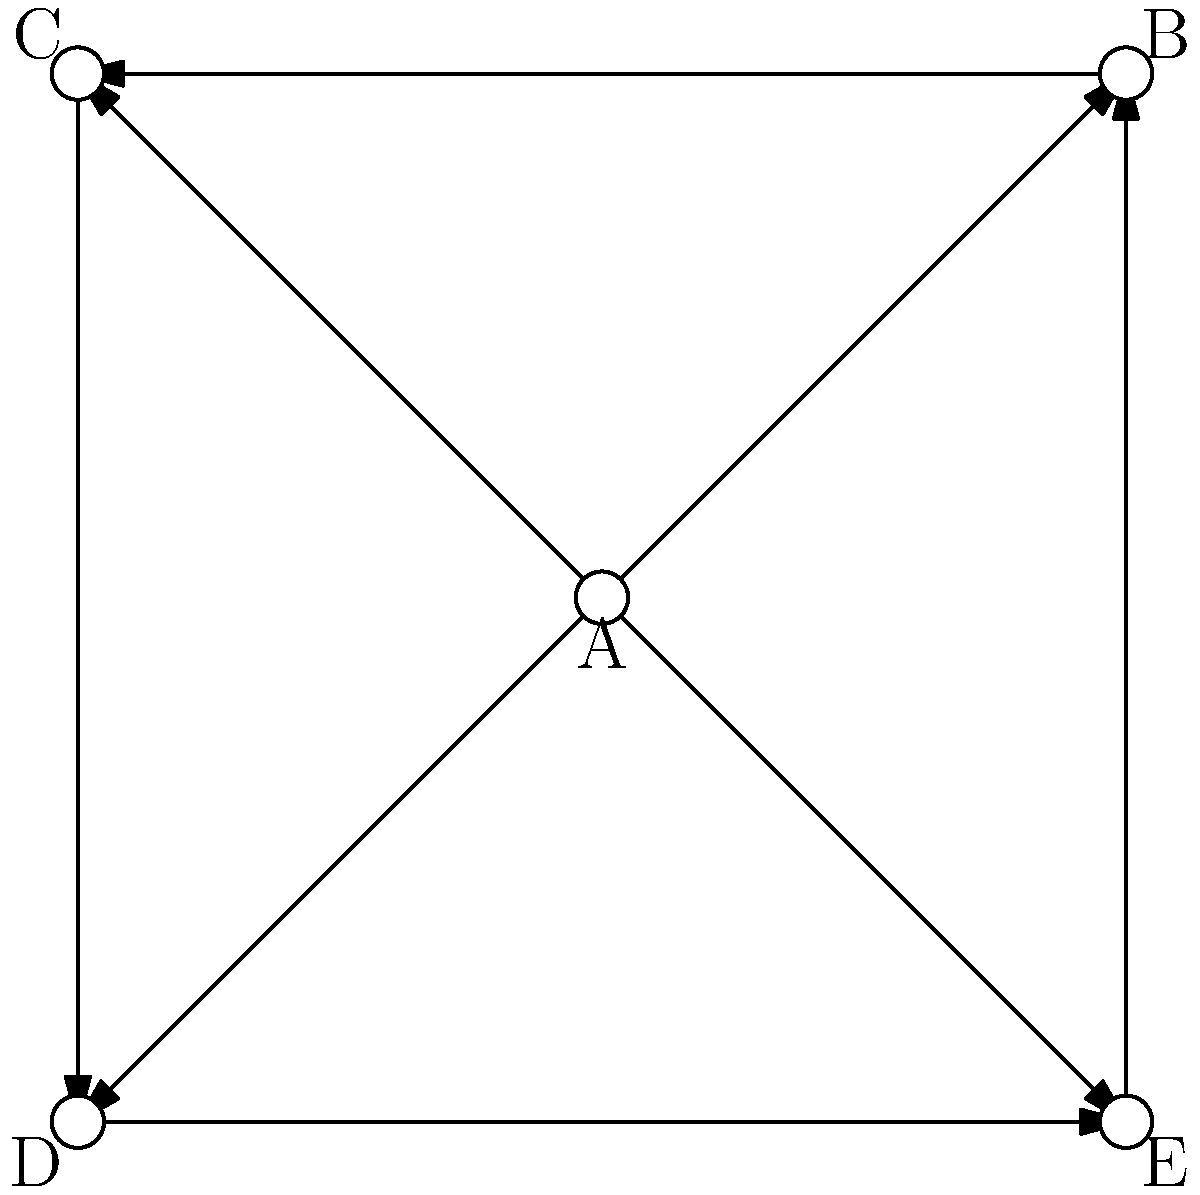In the given social network of financial analysts, which analyst has the highest betweenness centrality? Justify your answer using the concept of shortest paths. To determine the analyst with the highest betweenness centrality, we need to consider the number of shortest paths that pass through each node. Let's analyze this step-by-step:

1) Betweenness centrality measures the extent to which a node lies on the shortest paths between other nodes in the network.

2) For each pair of nodes, we need to count the number of shortest paths and how many of those pass through each node.

3) In this network:
   - A is on the direct path between any two non-adjacent nodes.
   - B, C, D, and E are only on paths that involve themselves and their immediate neighbors.

4) Let's count the shortest paths that pass through A:
   - B to C: 1 path through A (B-A-C)
   - B to D: 1 path through A (B-A-D)
   - C to E: 1 path through A (C-A-E)
   - D to E: 1 path through A (D-A-E)

5) A is on 4 shortest paths between non-adjacent nodes.

6) For B, C, D, and E, they are not on any shortest paths between other nodes, as A provides a direct connection in all cases.

7) Therefore, A has the highest betweenness centrality, as it acts as a bridge for information flow between all other analysts in the network.

This centrality indicates that analyst A is in a critical position to control or influence the flow of information between other financial analysts in this network.
Answer: A 